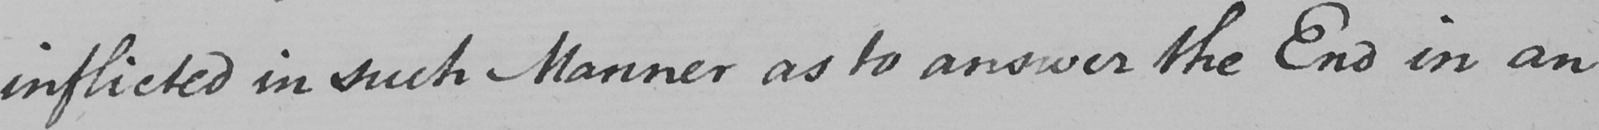Please transcribe the handwritten text in this image. inflicted in such a Manner as to answer the End in an 